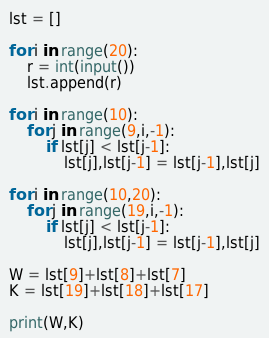<code> <loc_0><loc_0><loc_500><loc_500><_Python_>lst = []

for i in range(20):
    r = int(input())
    lst.append(r)
    
for i in range(10):
    for j in range(9,i,-1):
        if lst[j] < lst[j-1]:
            lst[j],lst[j-1] = lst[j-1],lst[j]

for i in range(10,20):
    for j in range(19,i,-1):
        if lst[j] < lst[j-1]:
            lst[j],lst[j-1] = lst[j-1],lst[j]

W = lst[9]+lst[8]+lst[7]
K = lst[19]+lst[18]+lst[17]

print(W,K)
</code> 